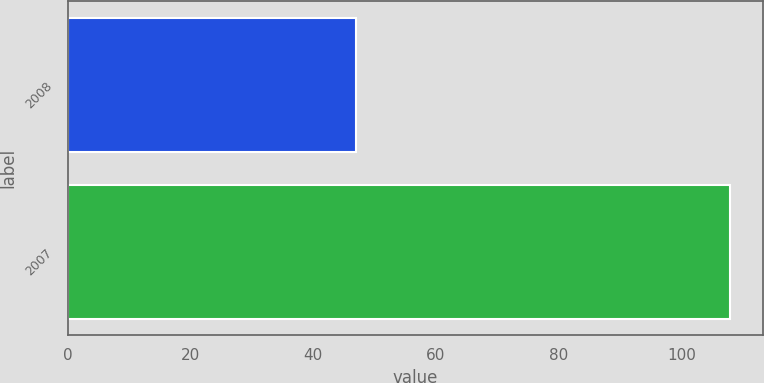<chart> <loc_0><loc_0><loc_500><loc_500><bar_chart><fcel>2008<fcel>2007<nl><fcel>47<fcel>108<nl></chart> 